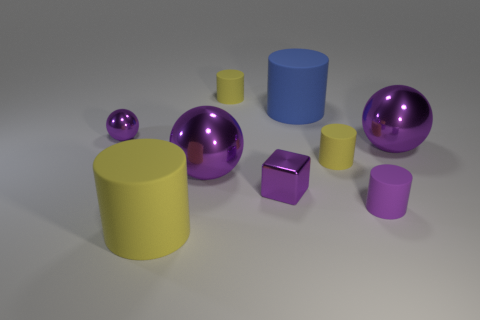Subtract all red blocks. How many yellow cylinders are left? 3 Subtract all tiny purple matte cylinders. How many cylinders are left? 4 Subtract 3 cylinders. How many cylinders are left? 2 Subtract all blue cylinders. How many cylinders are left? 4 Subtract all green cylinders. Subtract all red spheres. How many cylinders are left? 5 Subtract all blocks. How many objects are left? 8 Add 5 blue matte things. How many blue matte things are left? 6 Add 5 large brown shiny cylinders. How many large brown shiny cylinders exist? 5 Subtract 1 blue cylinders. How many objects are left? 8 Subtract all small shiny spheres. Subtract all yellow matte things. How many objects are left? 5 